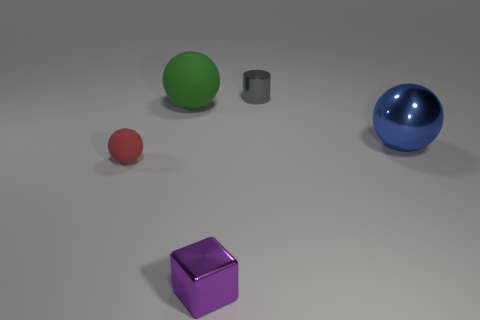The small metal thing that is to the left of the tiny object behind the matte object behind the small red matte ball is what shape?
Offer a terse response. Cube. How big is the metallic cube?
Provide a short and direct response. Small. What is the shape of the small red object that is the same material as the green thing?
Ensure brevity in your answer.  Sphere. Is the number of things that are in front of the gray metal thing less than the number of large rubber balls?
Keep it short and to the point. No. There is a big ball left of the tiny cylinder; what is its color?
Make the answer very short. Green. Is there a large blue metal object that has the same shape as the green rubber thing?
Provide a succinct answer. Yes. What number of green things are the same shape as the blue metal object?
Keep it short and to the point. 1. Are there fewer purple objects than large objects?
Ensure brevity in your answer.  Yes. There is a cube in front of the small red thing; what material is it?
Offer a terse response. Metal. There is a purple thing that is the same size as the metal cylinder; what is its material?
Offer a terse response. Metal. 